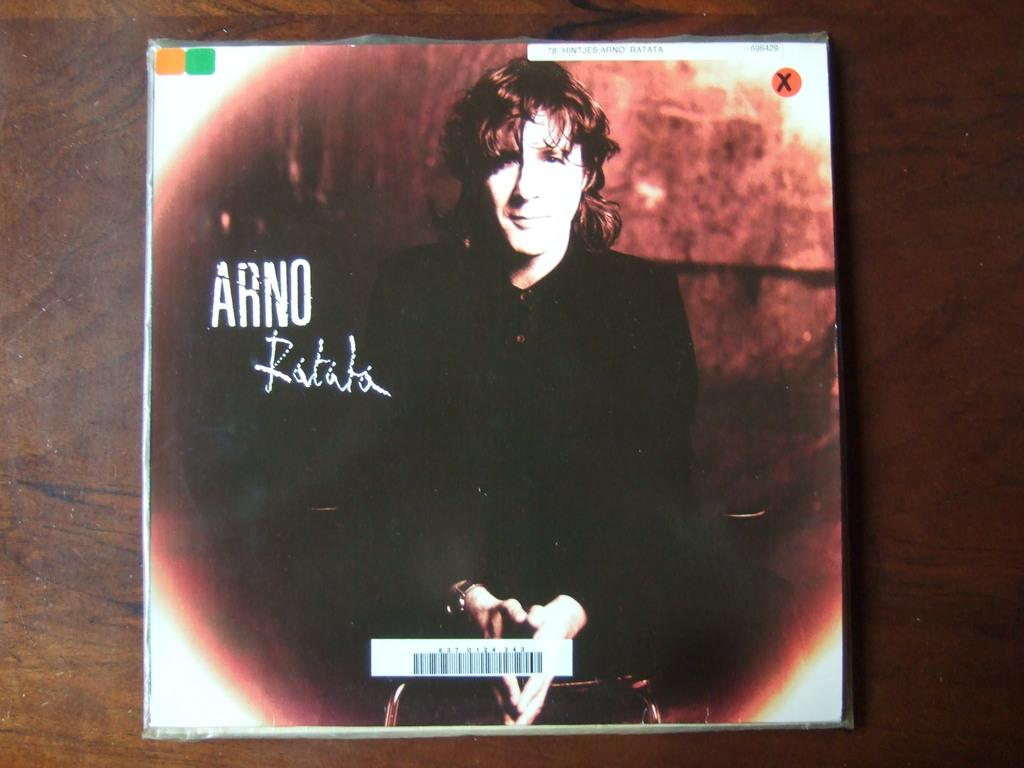What is the main subject of the image? The main subject of the image is a compact disc cover. What can be seen on the compact disc cover? There is a picture of a person on the compact disc cover. What type of guitar is the person holding in the image? There is no guitar present in the image; it only features a picture of a person on the compact disc cover. How does the person's heart rate appear in the image? There is no indication of the person's heart rate in the image, as it only shows a picture of a person on the compact disc cover. 